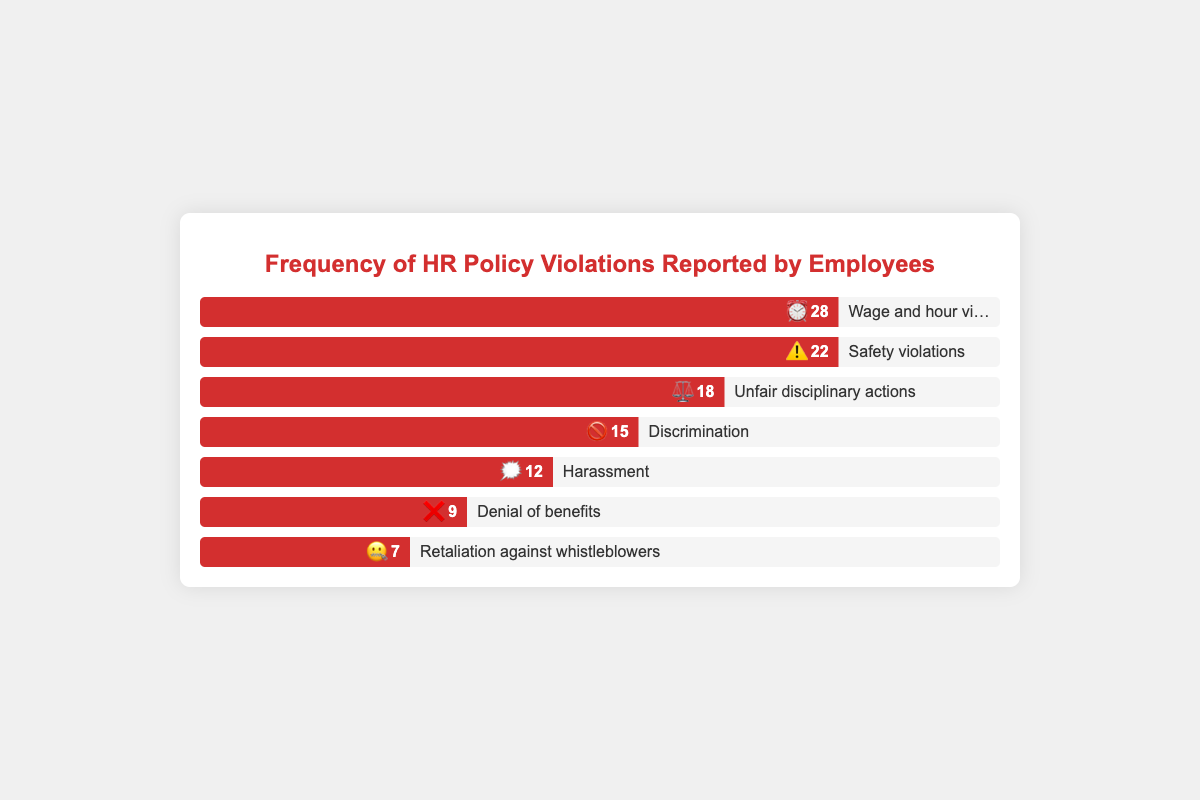What is the most frequently reported HR policy violation? The most frequently reported HR policy violation can be identified by looking for the bar with the highest percentage width. The "Wage and hour violations" bar is the longest with a frequency of 28.
Answer: Wage and hour violations Which HR policy violation is denoted with an emoji of ⏰? The emoji ⏰ is associated with "Wage and hour violations" as indicated next to the respective bar in the chart.
Answer: Wage and hour violations How many HR policy violations are denoted by the emoji ⚠️ and ✖️ altogether? The frequencies for “Safety violations” (⚠️) and “Denial of benefits” (✖️) need to be summed. The frequencies are 22 and 9, respectively. The sum is 22 + 9 = 31.
Answer: 31 Which type of violation has exactly half the frequency of Wage and hour violations? Half of "Wage and hour violations" (frequency 28) is 14. The violation close to this value is "Discrimination" with a frequency of 15, which is the closest plausible answer.
Answer: Discrimination What is the least reported HR policy violation and its emoji? The least reported violation can be found by identifying the bar with the smallest width. "Retaliation against whistleblowers" with frequency 7 and emoji 🤐 is the smallest.
Answer: Retaliation against whistleblowers with 🤐 What is the combined frequency of "Unfair disciplinary actions" and "Harassment"? The frequencies need to be summed: "Unfair disciplinary actions" (18) and "Harassment" (12). The sum is 18 + 12 = 30.
Answer: 30 How many different types of HR policy violations are represented in the chart? Count the number of different bars/types presented in the chart. There are 7 different types of HR policy violations shown.
Answer: 7 Which violations have higher frequency than "Harassment"? Compare the frequencies of all violations to that of "Harassment" (12). "Wage and hour violations" (28), "Safety violations" (22), "Unfair disciplinary actions" (18), and "Discrimination" (15) are higher.
Answer: Wage and hour violations, Safety violations, Unfair disciplinary actions, Discrimination What’s the difference between the highest and lowest reported violations? Subtract the smallest frequency (7 for "Retaliation against whistleblowers") from the largest frequency (28 for "Wage and hour violations"). The difference is 28 - 7 = 21.
Answer: 21 